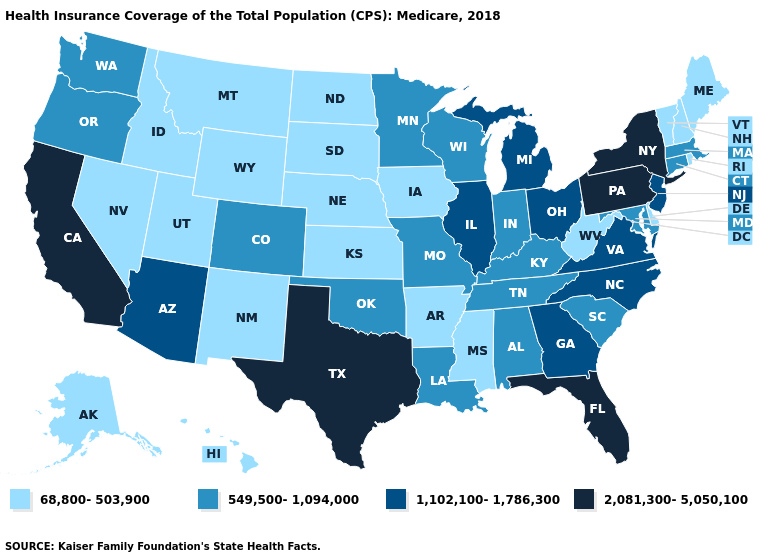How many symbols are there in the legend?
Be succinct. 4. What is the value of Missouri?
Quick response, please. 549,500-1,094,000. Name the states that have a value in the range 1,102,100-1,786,300?
Write a very short answer. Arizona, Georgia, Illinois, Michigan, New Jersey, North Carolina, Ohio, Virginia. Does Hawaii have the lowest value in the West?
Be succinct. Yes. What is the value of Minnesota?
Quick response, please. 549,500-1,094,000. Name the states that have a value in the range 68,800-503,900?
Quick response, please. Alaska, Arkansas, Delaware, Hawaii, Idaho, Iowa, Kansas, Maine, Mississippi, Montana, Nebraska, Nevada, New Hampshire, New Mexico, North Dakota, Rhode Island, South Dakota, Utah, Vermont, West Virginia, Wyoming. Name the states that have a value in the range 1,102,100-1,786,300?
Write a very short answer. Arizona, Georgia, Illinois, Michigan, New Jersey, North Carolina, Ohio, Virginia. Among the states that border Kentucky , which have the lowest value?
Quick response, please. West Virginia. What is the lowest value in the MidWest?
Give a very brief answer. 68,800-503,900. Which states have the lowest value in the USA?
Short answer required. Alaska, Arkansas, Delaware, Hawaii, Idaho, Iowa, Kansas, Maine, Mississippi, Montana, Nebraska, Nevada, New Hampshire, New Mexico, North Dakota, Rhode Island, South Dakota, Utah, Vermont, West Virginia, Wyoming. Which states have the highest value in the USA?
Keep it brief. California, Florida, New York, Pennsylvania, Texas. Name the states that have a value in the range 68,800-503,900?
Be succinct. Alaska, Arkansas, Delaware, Hawaii, Idaho, Iowa, Kansas, Maine, Mississippi, Montana, Nebraska, Nevada, New Hampshire, New Mexico, North Dakota, Rhode Island, South Dakota, Utah, Vermont, West Virginia, Wyoming. What is the value of North Dakota?
Concise answer only. 68,800-503,900. Is the legend a continuous bar?
Write a very short answer. No. 